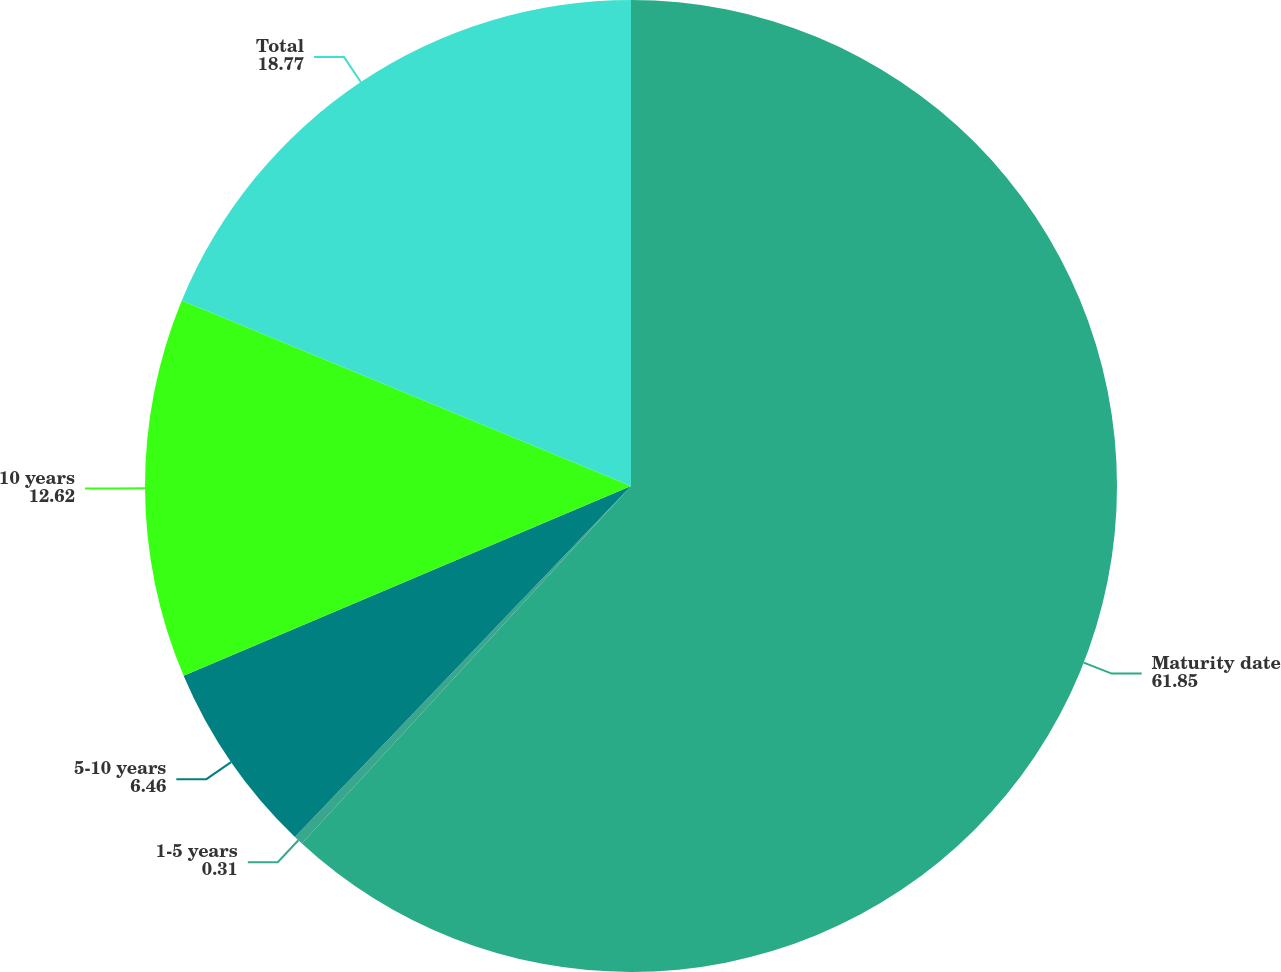<chart> <loc_0><loc_0><loc_500><loc_500><pie_chart><fcel>Maturity date<fcel>1-5 years<fcel>5-10 years<fcel>10 years<fcel>Total<nl><fcel>61.85%<fcel>0.31%<fcel>6.46%<fcel>12.62%<fcel>18.77%<nl></chart> 